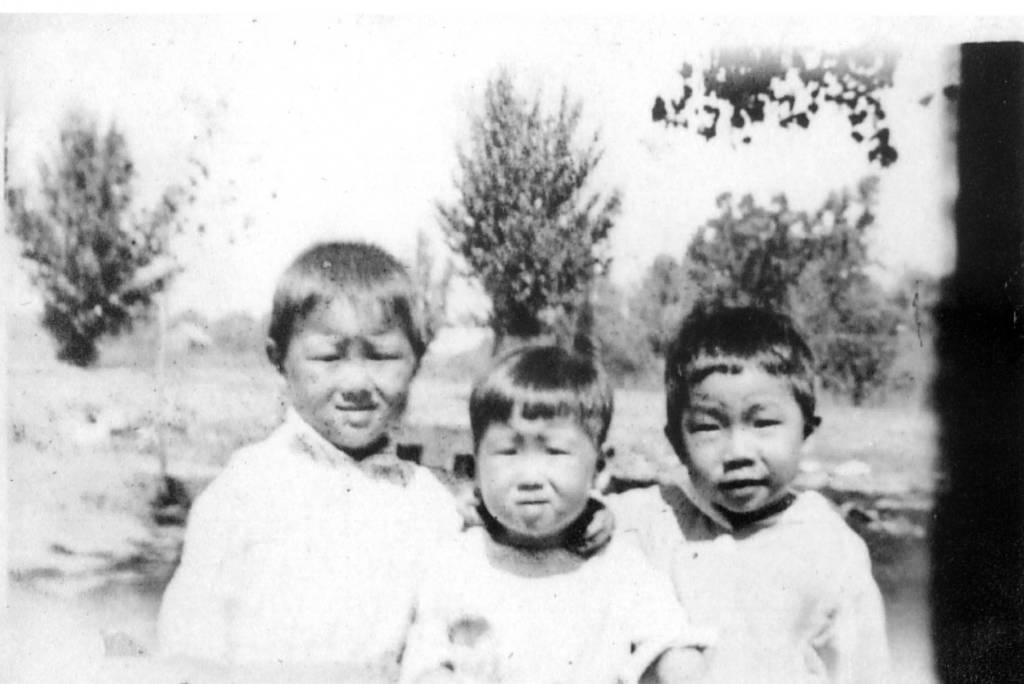How would you summarize this image in a sentence or two? As we can see in the image in the front there are three people wearing white color dresses. In the background there are trees. At the top there is sky. 